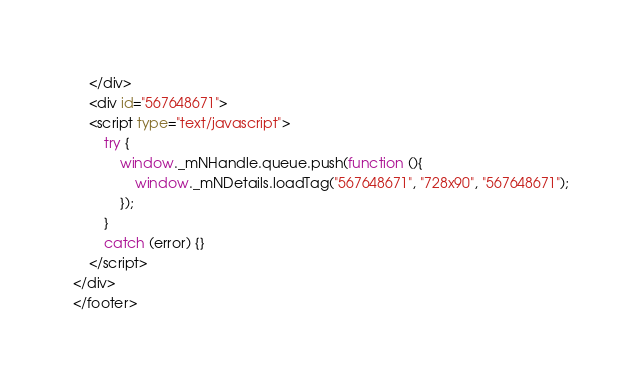Convert code to text. <code><loc_0><loc_0><loc_500><loc_500><_HTML_>	</div>
	<div id="567648671">
    <script type="text/javascript">
        try {
            window._mNHandle.queue.push(function (){
                window._mNDetails.loadTag("567648671", "728x90", "567648671");
            });
        }
        catch (error) {}
    </script>
</div>
</footer>
</code> 